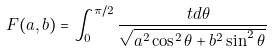<formula> <loc_0><loc_0><loc_500><loc_500>F ( a , b ) = \int _ { 0 } ^ { \pi / 2 } \frac { \ t d \theta } { \sqrt { a ^ { 2 } \cos ^ { 2 } \theta + b ^ { 2 } \sin ^ { 2 } \theta } \, }</formula> 